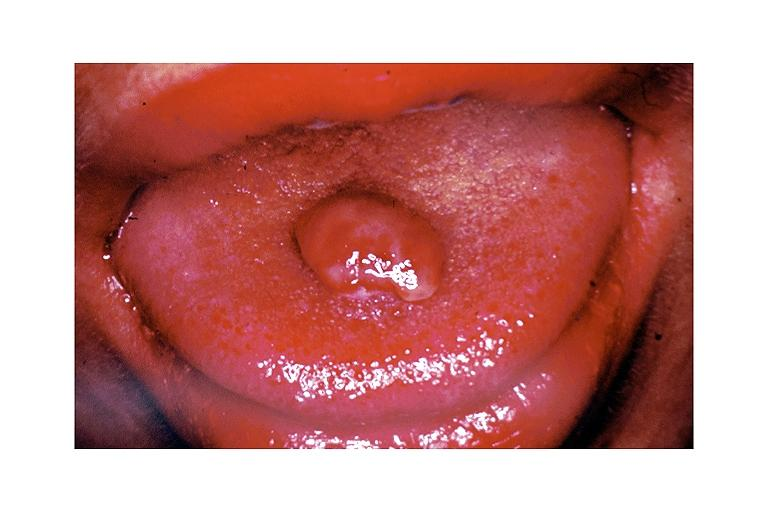does fixed tissue show pyogenic granuloma?
Answer the question using a single word or phrase. No 